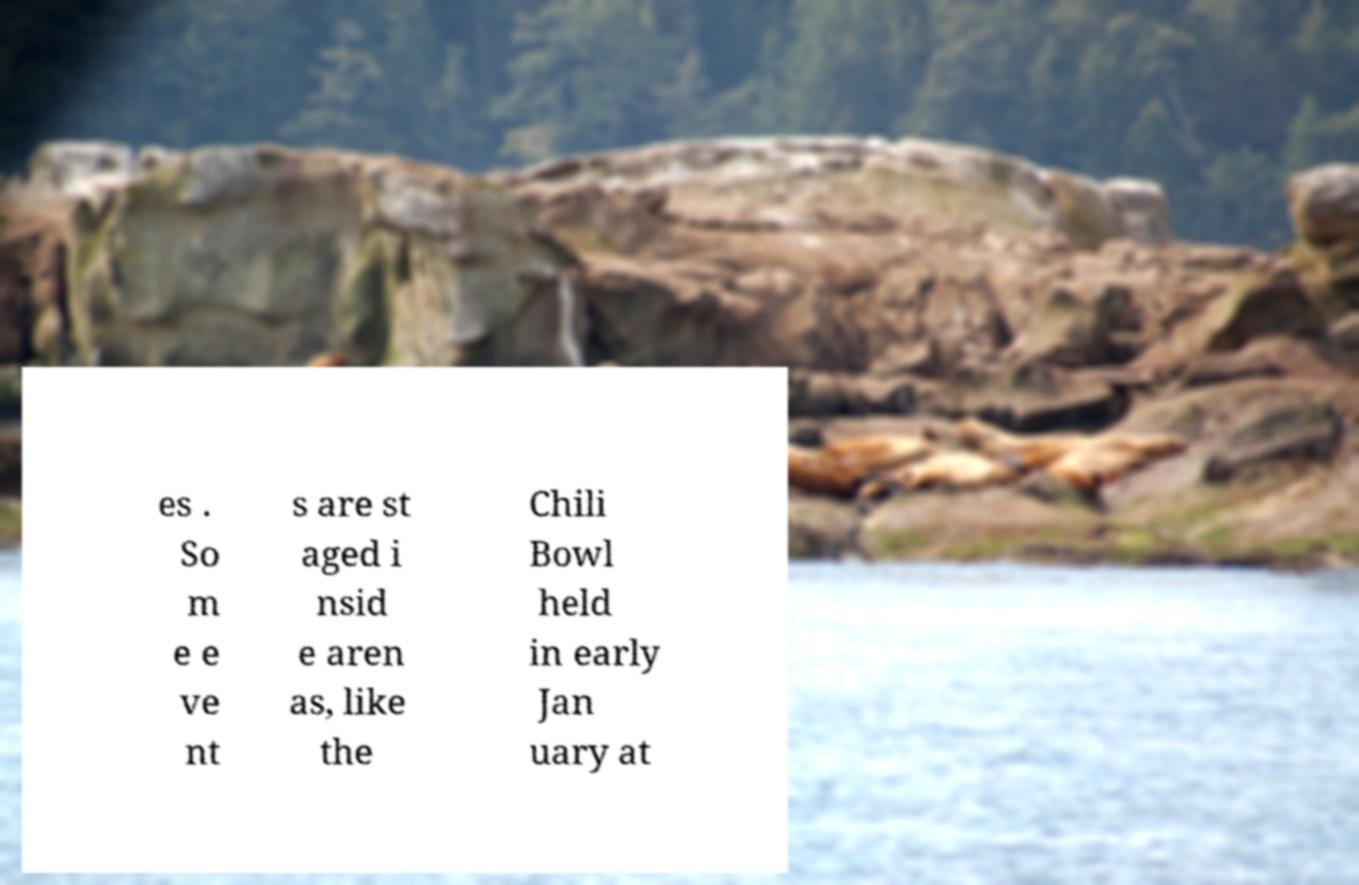For documentation purposes, I need the text within this image transcribed. Could you provide that? es . So m e e ve nt s are st aged i nsid e aren as, like the Chili Bowl held in early Jan uary at 